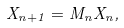Convert formula to latex. <formula><loc_0><loc_0><loc_500><loc_500>X _ { n + 1 } = M _ { n } X _ { n } ,</formula> 